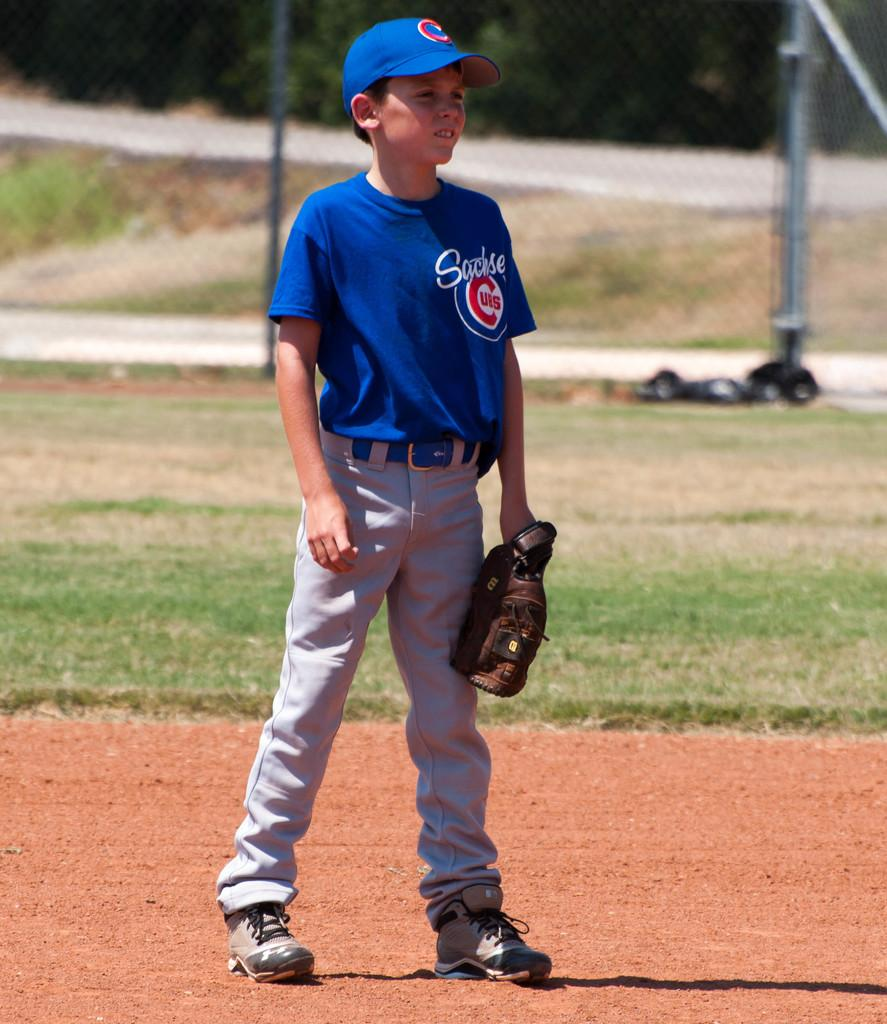<image>
Render a clear and concise summary of the photo. a boy catcher playing baseball with a Sachse Cubs uniform on. 